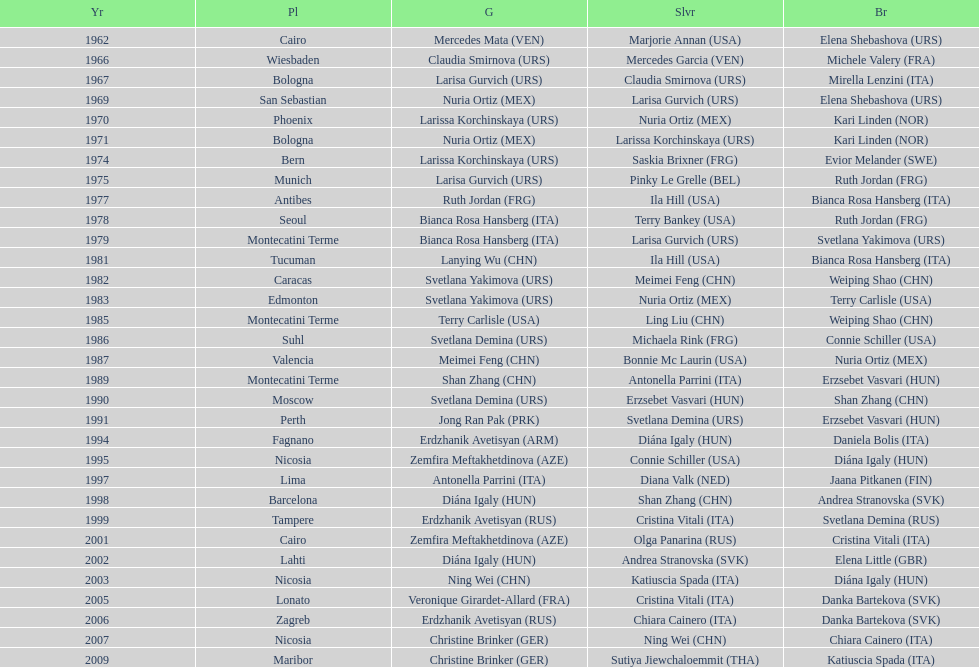What is the total number of gold medals won by the usa? 1. 